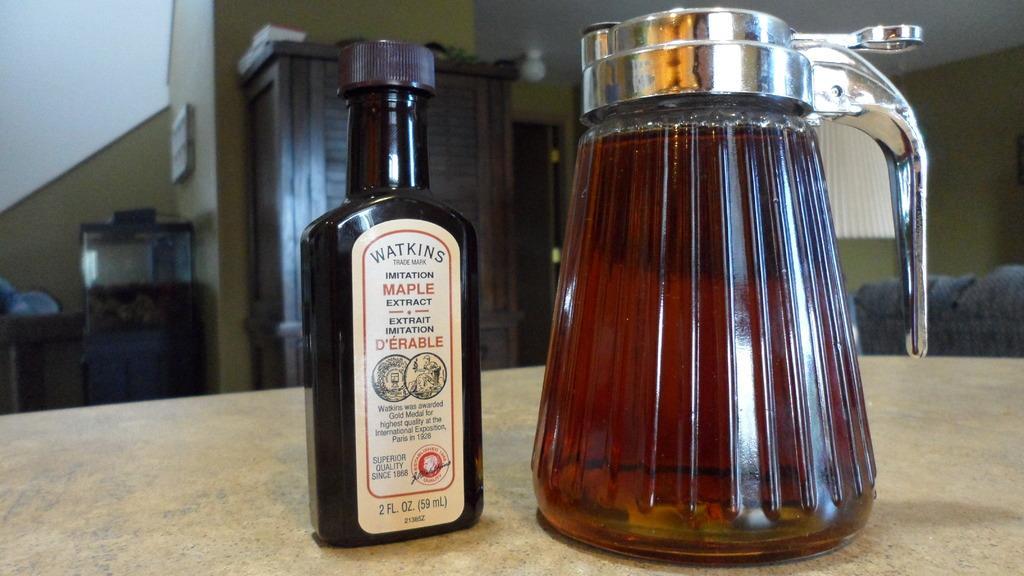Please provide a concise description of this image. In this picture we can see a bottle and an object on the wooden object. We can see other objects in the background. 